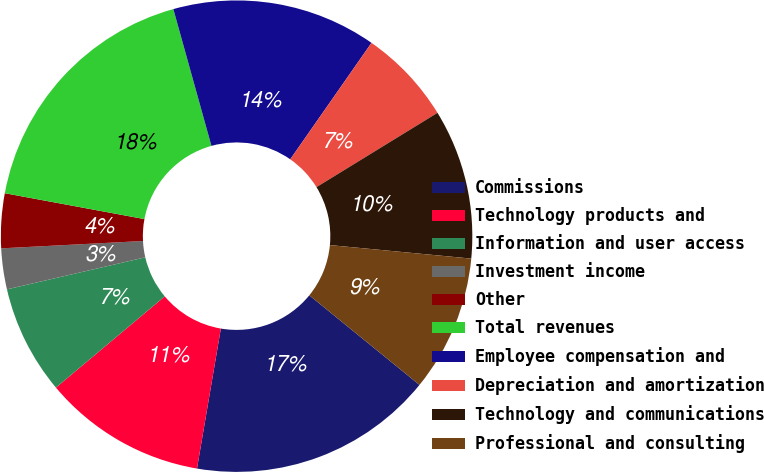Convert chart to OTSL. <chart><loc_0><loc_0><loc_500><loc_500><pie_chart><fcel>Commissions<fcel>Technology products and<fcel>Information and user access<fcel>Investment income<fcel>Other<fcel>Total revenues<fcel>Employee compensation and<fcel>Depreciation and amortization<fcel>Technology and communications<fcel>Professional and consulting<nl><fcel>16.82%<fcel>11.21%<fcel>7.48%<fcel>2.8%<fcel>3.74%<fcel>17.76%<fcel>14.02%<fcel>6.54%<fcel>10.28%<fcel>9.35%<nl></chart> 